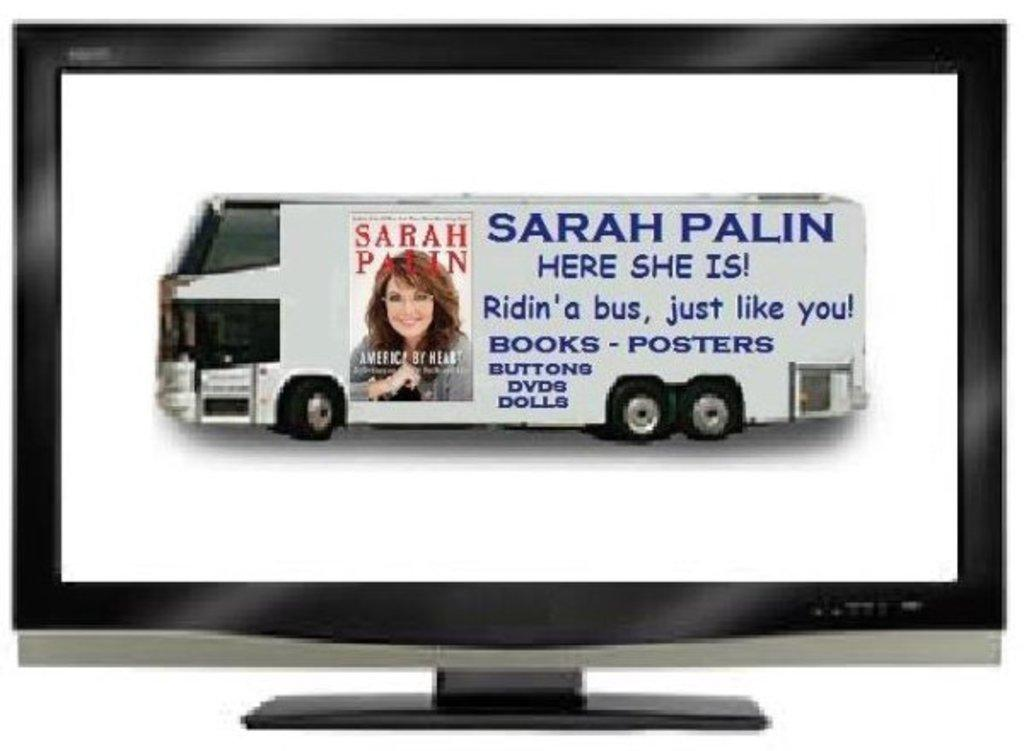Provide a one-sentence caption for the provided image. A picture of a bus with a Sarah Palin advertisement on it features a picture of her book cover. 